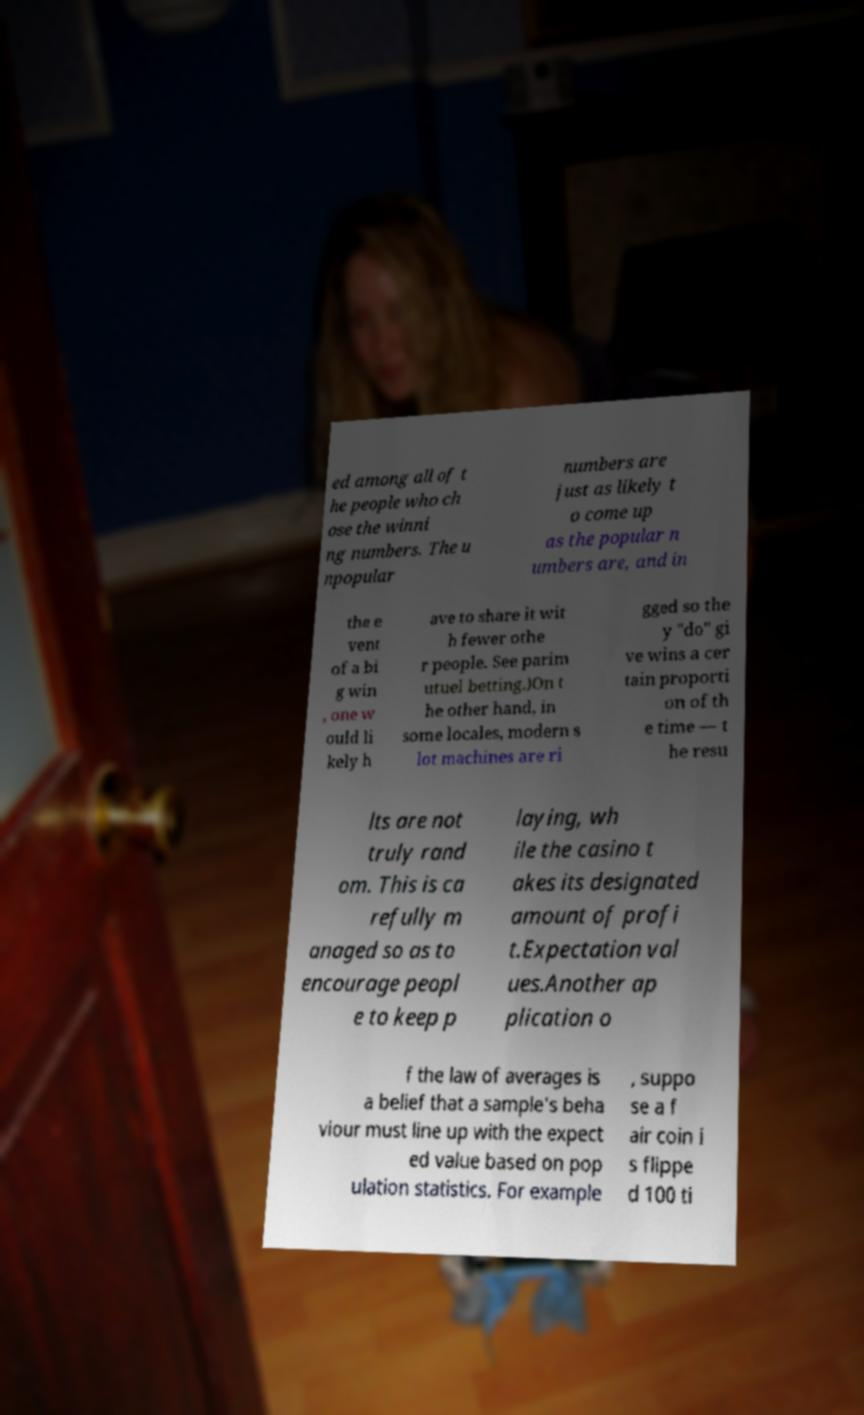Could you assist in decoding the text presented in this image and type it out clearly? ed among all of t he people who ch ose the winni ng numbers. The u npopular numbers are just as likely t o come up as the popular n umbers are, and in the e vent of a bi g win , one w ould li kely h ave to share it wit h fewer othe r people. See parim utuel betting.)On t he other hand, in some locales, modern s lot machines are ri gged so the y "do" gi ve wins a cer tain proporti on of th e time — t he resu lts are not truly rand om. This is ca refully m anaged so as to encourage peopl e to keep p laying, wh ile the casino t akes its designated amount of profi t.Expectation val ues.Another ap plication o f the law of averages is a belief that a sample's beha viour must line up with the expect ed value based on pop ulation statistics. For example , suppo se a f air coin i s flippe d 100 ti 